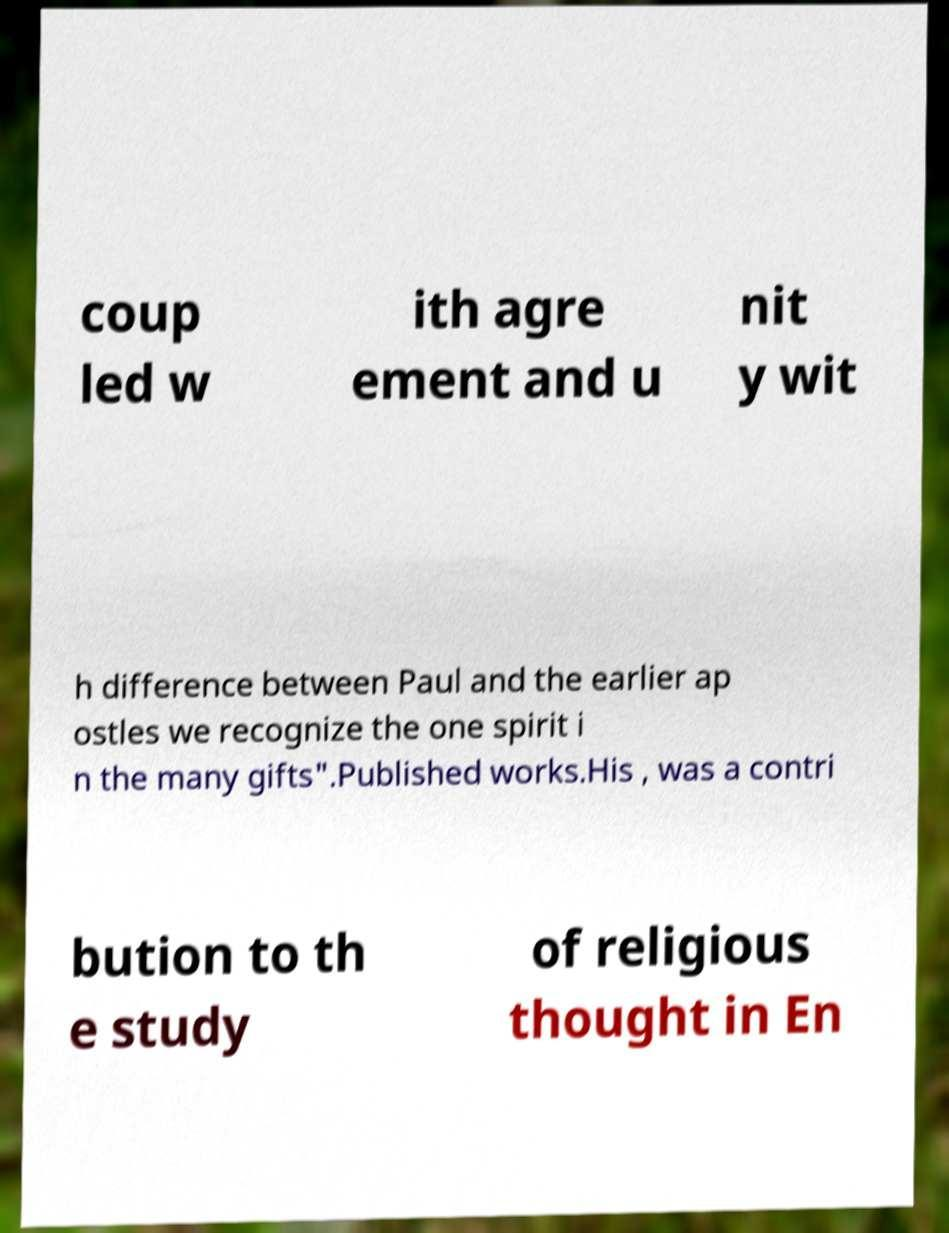There's text embedded in this image that I need extracted. Can you transcribe it verbatim? coup led w ith agre ement and u nit y wit h difference between Paul and the earlier ap ostles we recognize the one spirit i n the many gifts".Published works.His , was a contri bution to th e study of religious thought in En 